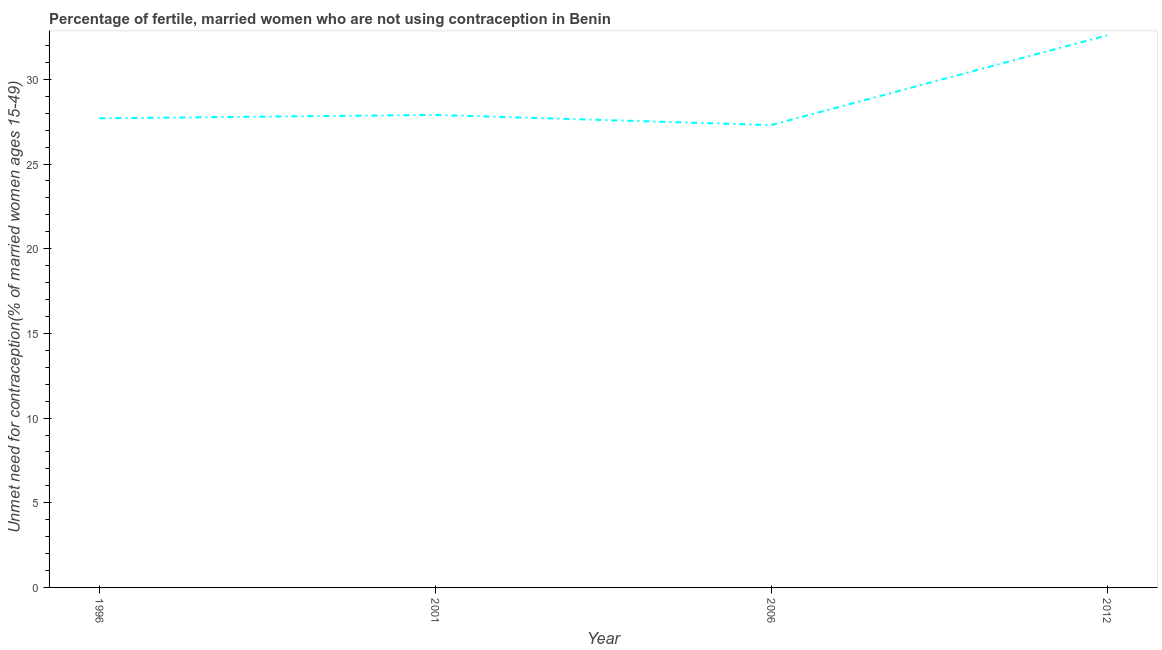What is the number of married women who are not using contraception in 2001?
Offer a terse response. 27.9. Across all years, what is the maximum number of married women who are not using contraception?
Provide a short and direct response. 32.6. Across all years, what is the minimum number of married women who are not using contraception?
Offer a terse response. 27.3. What is the sum of the number of married women who are not using contraception?
Give a very brief answer. 115.5. What is the difference between the number of married women who are not using contraception in 2001 and 2012?
Your answer should be compact. -4.7. What is the average number of married women who are not using contraception per year?
Make the answer very short. 28.88. What is the median number of married women who are not using contraception?
Give a very brief answer. 27.8. Do a majority of the years between 1996 and 2012 (inclusive) have number of married women who are not using contraception greater than 4 %?
Make the answer very short. Yes. What is the ratio of the number of married women who are not using contraception in 1996 to that in 2012?
Keep it short and to the point. 0.85. What is the difference between the highest and the second highest number of married women who are not using contraception?
Keep it short and to the point. 4.7. What is the difference between the highest and the lowest number of married women who are not using contraception?
Your response must be concise. 5.3. How many lines are there?
Provide a succinct answer. 1. How many years are there in the graph?
Give a very brief answer. 4. What is the difference between two consecutive major ticks on the Y-axis?
Your answer should be compact. 5. Are the values on the major ticks of Y-axis written in scientific E-notation?
Give a very brief answer. No. What is the title of the graph?
Keep it short and to the point. Percentage of fertile, married women who are not using contraception in Benin. What is the label or title of the Y-axis?
Make the answer very short.  Unmet need for contraception(% of married women ages 15-49). What is the  Unmet need for contraception(% of married women ages 15-49) in 1996?
Your answer should be compact. 27.7. What is the  Unmet need for contraception(% of married women ages 15-49) of 2001?
Your answer should be compact. 27.9. What is the  Unmet need for contraception(% of married women ages 15-49) of 2006?
Make the answer very short. 27.3. What is the  Unmet need for contraception(% of married women ages 15-49) in 2012?
Offer a very short reply. 32.6. What is the difference between the  Unmet need for contraception(% of married women ages 15-49) in 1996 and 2006?
Offer a very short reply. 0.4. What is the difference between the  Unmet need for contraception(% of married women ages 15-49) in 2001 and 2012?
Ensure brevity in your answer.  -4.7. What is the difference between the  Unmet need for contraception(% of married women ages 15-49) in 2006 and 2012?
Offer a very short reply. -5.3. What is the ratio of the  Unmet need for contraception(% of married women ages 15-49) in 1996 to that in 2001?
Give a very brief answer. 0.99. What is the ratio of the  Unmet need for contraception(% of married women ages 15-49) in 1996 to that in 2012?
Offer a terse response. 0.85. What is the ratio of the  Unmet need for contraception(% of married women ages 15-49) in 2001 to that in 2006?
Your answer should be compact. 1.02. What is the ratio of the  Unmet need for contraception(% of married women ages 15-49) in 2001 to that in 2012?
Your answer should be very brief. 0.86. What is the ratio of the  Unmet need for contraception(% of married women ages 15-49) in 2006 to that in 2012?
Offer a terse response. 0.84. 